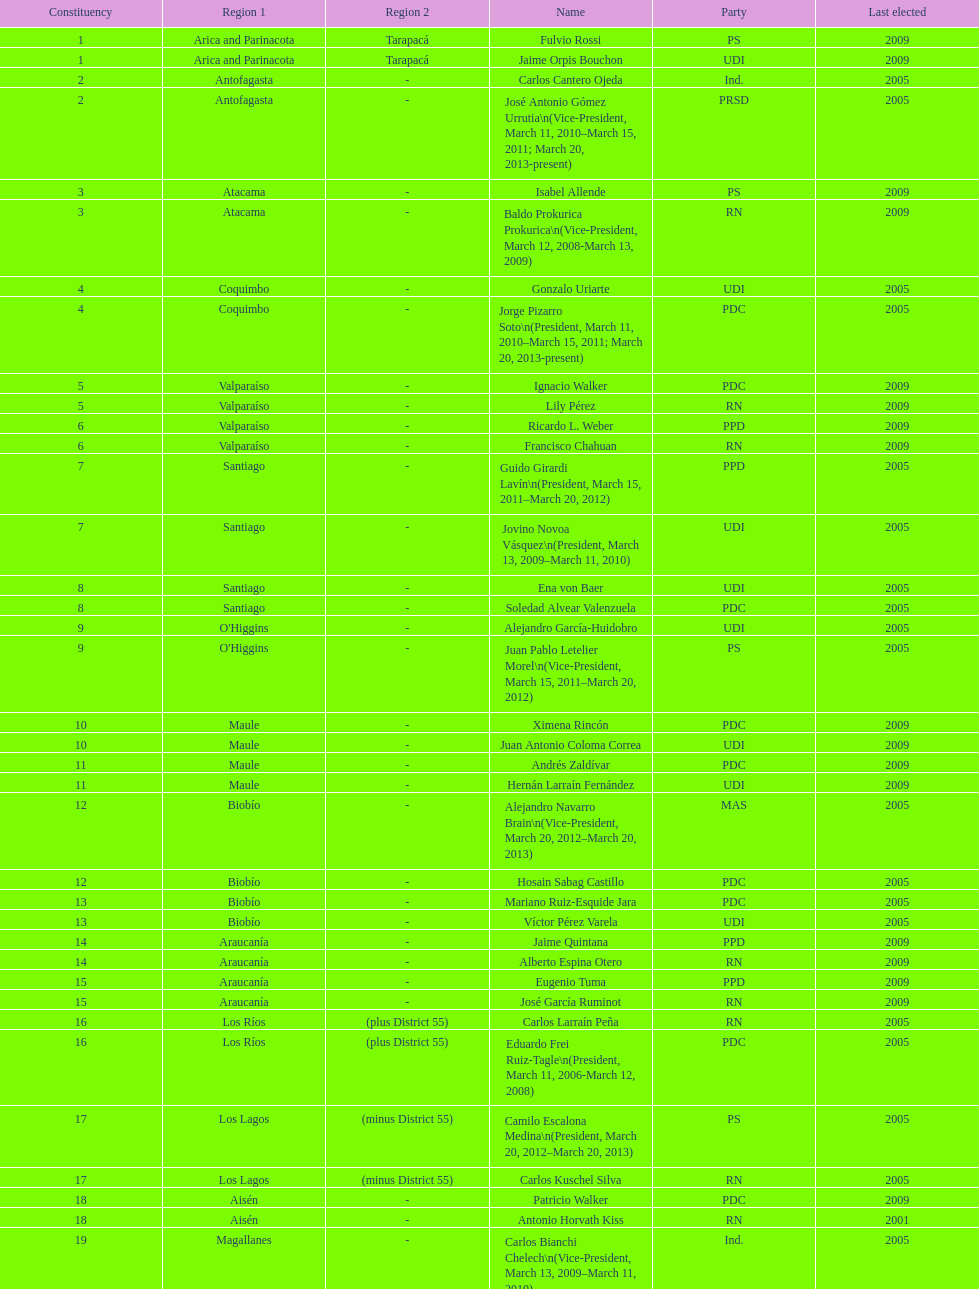How many total consituency are listed in the table? 19. 